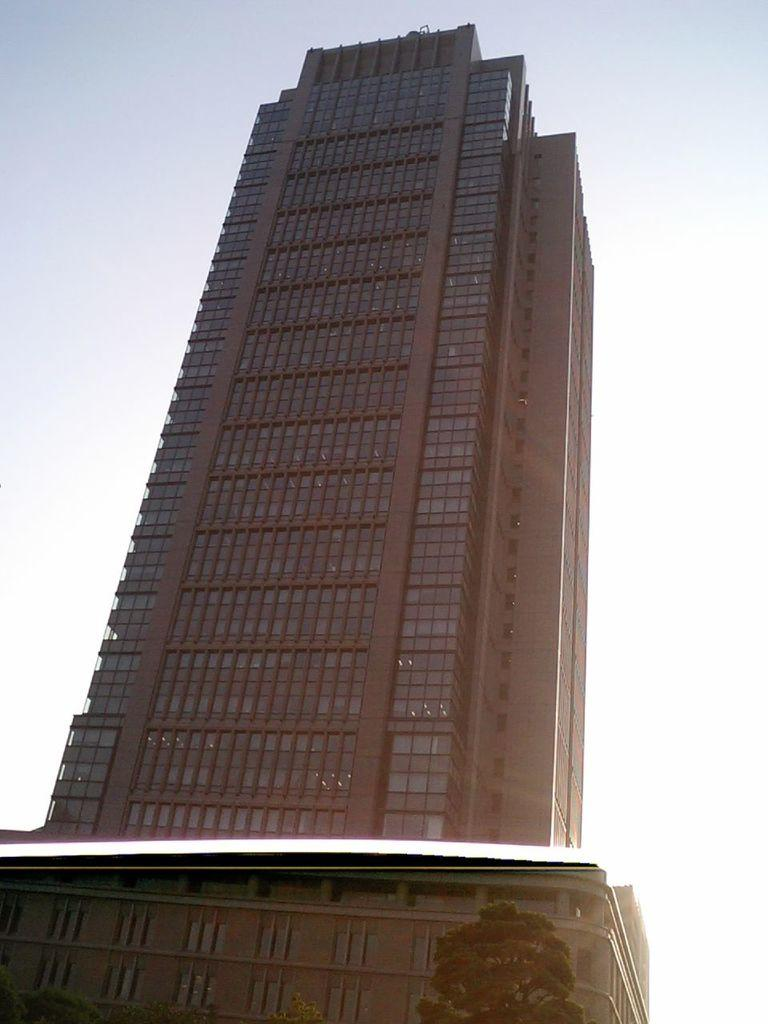What type of natural elements can be seen in the image? There are trees in the image. What type of man-made structures are present in the image? There are buildings in the image. What can be seen in the distance in the image? The sky is visible in the background of the image. What type of jeans is the tree wearing in the image? There are no jeans present in the image, as trees are natural elements and do not wear clothing. 